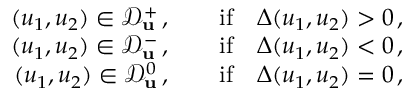Convert formula to latex. <formula><loc_0><loc_0><loc_500><loc_500>\begin{array} { r } { ( u _ { 1 } , u _ { 2 } ) \in \mathcal { D } _ { u } ^ { + } \, , \quad i f \quad \Delta ( u _ { 1 } , u _ { 2 } ) > 0 \, , } \\ { ( u _ { 1 } , u _ { 2 } ) \in \mathcal { D } _ { u } ^ { - } \, , \quad i f \quad \Delta ( u _ { 1 } , u _ { 2 } ) < 0 \, , } \\ { ( u _ { 1 } , u _ { 2 } ) \in \mathcal { D } _ { u } ^ { 0 } \, , \quad i f \quad \Delta ( u _ { 1 } , u _ { 2 } ) = 0 \, , } \end{array}</formula> 